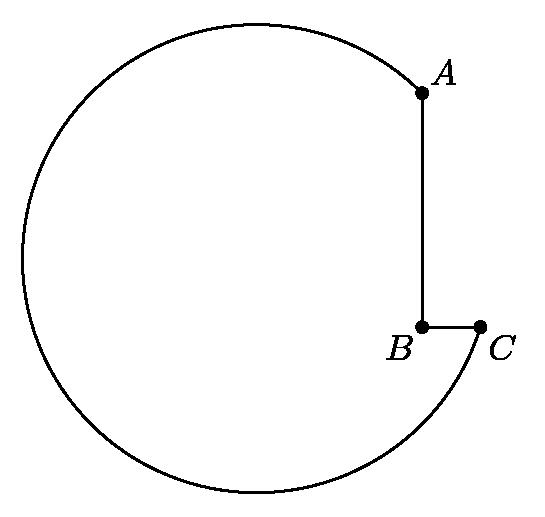Could you explain why this particular geometric shape might be useful in a machine-shop environment? This shape is particularly beneficial in a machine-shop due to its notched circle design, which can be advantageous for mounting or interfacing with other mechanical components. The notches provide potential points for secure attachment, ensuring that components are held precisely in place during machining processes. 